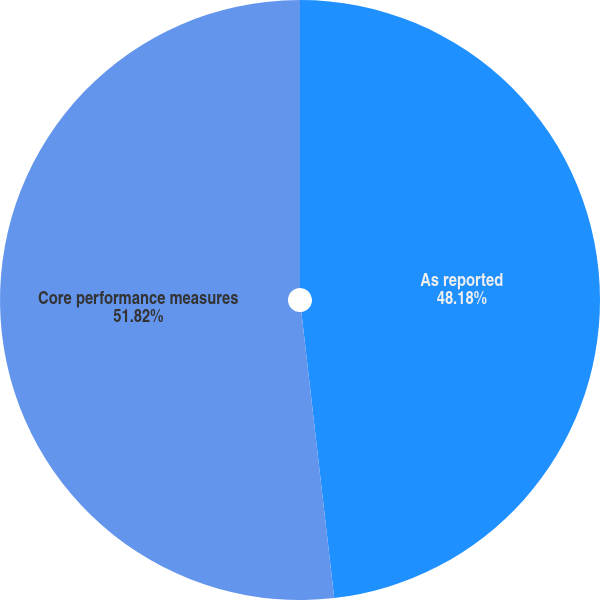Convert chart. <chart><loc_0><loc_0><loc_500><loc_500><pie_chart><fcel>As reported<fcel>Core performance measures<nl><fcel>48.18%<fcel>51.82%<nl></chart> 